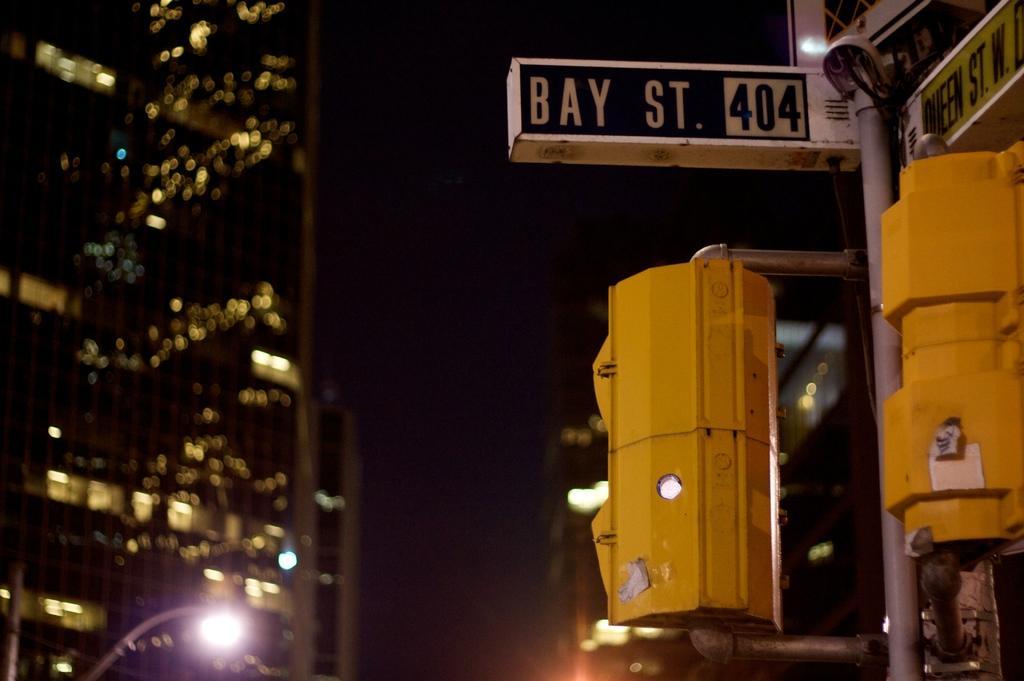Can you describe this image briefly? In this image we can see buildings, poles, lights, boxes, there are boards with some text on it, and the background is dark. 